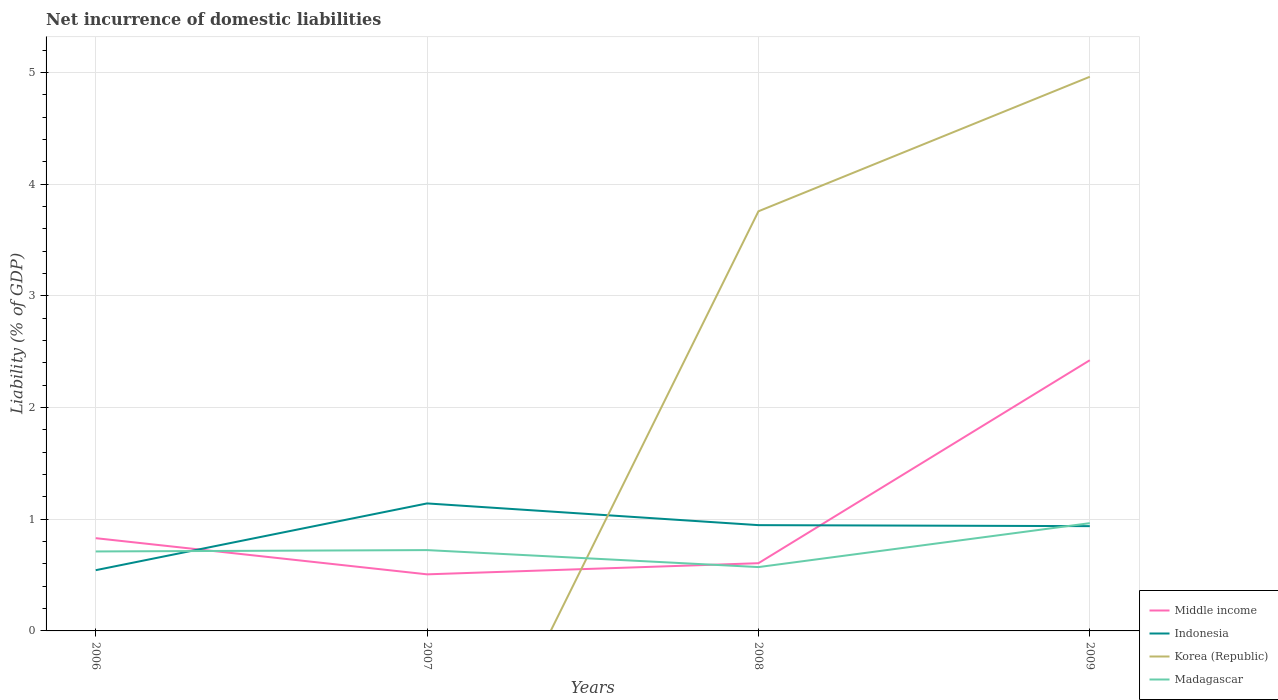How many different coloured lines are there?
Ensure brevity in your answer.  4. Is the number of lines equal to the number of legend labels?
Your answer should be very brief. No. Across all years, what is the maximum net incurrence of domestic liabilities in Madagascar?
Offer a very short reply. 0.57. What is the total net incurrence of domestic liabilities in Madagascar in the graph?
Provide a succinct answer. -0.25. What is the difference between the highest and the second highest net incurrence of domestic liabilities in Madagascar?
Make the answer very short. 0.39. Is the net incurrence of domestic liabilities in Korea (Republic) strictly greater than the net incurrence of domestic liabilities in Indonesia over the years?
Make the answer very short. No. How many years are there in the graph?
Your answer should be very brief. 4. Does the graph contain any zero values?
Provide a short and direct response. Yes. Does the graph contain grids?
Keep it short and to the point. Yes. Where does the legend appear in the graph?
Your response must be concise. Bottom right. How are the legend labels stacked?
Provide a succinct answer. Vertical. What is the title of the graph?
Keep it short and to the point. Net incurrence of domestic liabilities. What is the label or title of the X-axis?
Make the answer very short. Years. What is the label or title of the Y-axis?
Offer a terse response. Liability (% of GDP). What is the Liability (% of GDP) in Middle income in 2006?
Give a very brief answer. 0.83. What is the Liability (% of GDP) of Indonesia in 2006?
Your answer should be compact. 0.54. What is the Liability (% of GDP) of Korea (Republic) in 2006?
Provide a succinct answer. 0. What is the Liability (% of GDP) of Madagascar in 2006?
Provide a succinct answer. 0.71. What is the Liability (% of GDP) in Middle income in 2007?
Offer a very short reply. 0.51. What is the Liability (% of GDP) in Indonesia in 2007?
Offer a terse response. 1.14. What is the Liability (% of GDP) of Madagascar in 2007?
Offer a very short reply. 0.72. What is the Liability (% of GDP) of Middle income in 2008?
Provide a succinct answer. 0.61. What is the Liability (% of GDP) in Indonesia in 2008?
Make the answer very short. 0.95. What is the Liability (% of GDP) of Korea (Republic) in 2008?
Give a very brief answer. 3.76. What is the Liability (% of GDP) of Madagascar in 2008?
Provide a short and direct response. 0.57. What is the Liability (% of GDP) in Middle income in 2009?
Offer a very short reply. 2.42. What is the Liability (% of GDP) of Indonesia in 2009?
Keep it short and to the point. 0.94. What is the Liability (% of GDP) in Korea (Republic) in 2009?
Offer a terse response. 4.96. What is the Liability (% of GDP) of Madagascar in 2009?
Your answer should be compact. 0.97. Across all years, what is the maximum Liability (% of GDP) of Middle income?
Ensure brevity in your answer.  2.42. Across all years, what is the maximum Liability (% of GDP) of Indonesia?
Offer a terse response. 1.14. Across all years, what is the maximum Liability (% of GDP) in Korea (Republic)?
Your answer should be very brief. 4.96. Across all years, what is the maximum Liability (% of GDP) of Madagascar?
Your response must be concise. 0.97. Across all years, what is the minimum Liability (% of GDP) in Middle income?
Make the answer very short. 0.51. Across all years, what is the minimum Liability (% of GDP) in Indonesia?
Make the answer very short. 0.54. Across all years, what is the minimum Liability (% of GDP) in Madagascar?
Provide a short and direct response. 0.57. What is the total Liability (% of GDP) of Middle income in the graph?
Your answer should be compact. 4.37. What is the total Liability (% of GDP) of Indonesia in the graph?
Ensure brevity in your answer.  3.57. What is the total Liability (% of GDP) in Korea (Republic) in the graph?
Provide a short and direct response. 8.72. What is the total Liability (% of GDP) of Madagascar in the graph?
Your answer should be compact. 2.97. What is the difference between the Liability (% of GDP) in Middle income in 2006 and that in 2007?
Provide a short and direct response. 0.32. What is the difference between the Liability (% of GDP) in Indonesia in 2006 and that in 2007?
Ensure brevity in your answer.  -0.6. What is the difference between the Liability (% of GDP) in Madagascar in 2006 and that in 2007?
Offer a terse response. -0.01. What is the difference between the Liability (% of GDP) in Middle income in 2006 and that in 2008?
Provide a short and direct response. 0.22. What is the difference between the Liability (% of GDP) in Indonesia in 2006 and that in 2008?
Make the answer very short. -0.4. What is the difference between the Liability (% of GDP) of Madagascar in 2006 and that in 2008?
Ensure brevity in your answer.  0.14. What is the difference between the Liability (% of GDP) of Middle income in 2006 and that in 2009?
Provide a succinct answer. -1.59. What is the difference between the Liability (% of GDP) in Indonesia in 2006 and that in 2009?
Provide a short and direct response. -0.39. What is the difference between the Liability (% of GDP) of Madagascar in 2006 and that in 2009?
Give a very brief answer. -0.25. What is the difference between the Liability (% of GDP) in Middle income in 2007 and that in 2008?
Provide a short and direct response. -0.1. What is the difference between the Liability (% of GDP) of Indonesia in 2007 and that in 2008?
Your response must be concise. 0.19. What is the difference between the Liability (% of GDP) of Madagascar in 2007 and that in 2008?
Offer a terse response. 0.15. What is the difference between the Liability (% of GDP) of Middle income in 2007 and that in 2009?
Provide a short and direct response. -1.92. What is the difference between the Liability (% of GDP) in Indonesia in 2007 and that in 2009?
Provide a succinct answer. 0.2. What is the difference between the Liability (% of GDP) of Madagascar in 2007 and that in 2009?
Offer a very short reply. -0.24. What is the difference between the Liability (% of GDP) of Middle income in 2008 and that in 2009?
Provide a short and direct response. -1.82. What is the difference between the Liability (% of GDP) in Indonesia in 2008 and that in 2009?
Your answer should be compact. 0.01. What is the difference between the Liability (% of GDP) of Korea (Republic) in 2008 and that in 2009?
Keep it short and to the point. -1.2. What is the difference between the Liability (% of GDP) of Madagascar in 2008 and that in 2009?
Provide a short and direct response. -0.39. What is the difference between the Liability (% of GDP) of Middle income in 2006 and the Liability (% of GDP) of Indonesia in 2007?
Keep it short and to the point. -0.31. What is the difference between the Liability (% of GDP) in Middle income in 2006 and the Liability (% of GDP) in Madagascar in 2007?
Your answer should be very brief. 0.11. What is the difference between the Liability (% of GDP) in Indonesia in 2006 and the Liability (% of GDP) in Madagascar in 2007?
Ensure brevity in your answer.  -0.18. What is the difference between the Liability (% of GDP) in Middle income in 2006 and the Liability (% of GDP) in Indonesia in 2008?
Provide a short and direct response. -0.12. What is the difference between the Liability (% of GDP) in Middle income in 2006 and the Liability (% of GDP) in Korea (Republic) in 2008?
Your answer should be compact. -2.93. What is the difference between the Liability (% of GDP) of Middle income in 2006 and the Liability (% of GDP) of Madagascar in 2008?
Offer a terse response. 0.26. What is the difference between the Liability (% of GDP) in Indonesia in 2006 and the Liability (% of GDP) in Korea (Republic) in 2008?
Make the answer very short. -3.21. What is the difference between the Liability (% of GDP) of Indonesia in 2006 and the Liability (% of GDP) of Madagascar in 2008?
Keep it short and to the point. -0.03. What is the difference between the Liability (% of GDP) in Middle income in 2006 and the Liability (% of GDP) in Indonesia in 2009?
Make the answer very short. -0.11. What is the difference between the Liability (% of GDP) of Middle income in 2006 and the Liability (% of GDP) of Korea (Republic) in 2009?
Offer a terse response. -4.13. What is the difference between the Liability (% of GDP) in Middle income in 2006 and the Liability (% of GDP) in Madagascar in 2009?
Offer a terse response. -0.13. What is the difference between the Liability (% of GDP) in Indonesia in 2006 and the Liability (% of GDP) in Korea (Republic) in 2009?
Offer a very short reply. -4.42. What is the difference between the Liability (% of GDP) of Indonesia in 2006 and the Liability (% of GDP) of Madagascar in 2009?
Give a very brief answer. -0.42. What is the difference between the Liability (% of GDP) of Middle income in 2007 and the Liability (% of GDP) of Indonesia in 2008?
Give a very brief answer. -0.44. What is the difference between the Liability (% of GDP) in Middle income in 2007 and the Liability (% of GDP) in Korea (Republic) in 2008?
Offer a terse response. -3.25. What is the difference between the Liability (% of GDP) in Middle income in 2007 and the Liability (% of GDP) in Madagascar in 2008?
Ensure brevity in your answer.  -0.07. What is the difference between the Liability (% of GDP) of Indonesia in 2007 and the Liability (% of GDP) of Korea (Republic) in 2008?
Provide a short and direct response. -2.62. What is the difference between the Liability (% of GDP) of Indonesia in 2007 and the Liability (% of GDP) of Madagascar in 2008?
Ensure brevity in your answer.  0.57. What is the difference between the Liability (% of GDP) in Middle income in 2007 and the Liability (% of GDP) in Indonesia in 2009?
Give a very brief answer. -0.43. What is the difference between the Liability (% of GDP) in Middle income in 2007 and the Liability (% of GDP) in Korea (Republic) in 2009?
Ensure brevity in your answer.  -4.46. What is the difference between the Liability (% of GDP) of Middle income in 2007 and the Liability (% of GDP) of Madagascar in 2009?
Make the answer very short. -0.46. What is the difference between the Liability (% of GDP) in Indonesia in 2007 and the Liability (% of GDP) in Korea (Republic) in 2009?
Make the answer very short. -3.82. What is the difference between the Liability (% of GDP) of Indonesia in 2007 and the Liability (% of GDP) of Madagascar in 2009?
Give a very brief answer. 0.18. What is the difference between the Liability (% of GDP) in Middle income in 2008 and the Liability (% of GDP) in Indonesia in 2009?
Your answer should be very brief. -0.33. What is the difference between the Liability (% of GDP) in Middle income in 2008 and the Liability (% of GDP) in Korea (Republic) in 2009?
Offer a terse response. -4.36. What is the difference between the Liability (% of GDP) of Middle income in 2008 and the Liability (% of GDP) of Madagascar in 2009?
Ensure brevity in your answer.  -0.36. What is the difference between the Liability (% of GDP) of Indonesia in 2008 and the Liability (% of GDP) of Korea (Republic) in 2009?
Ensure brevity in your answer.  -4.02. What is the difference between the Liability (% of GDP) of Indonesia in 2008 and the Liability (% of GDP) of Madagascar in 2009?
Offer a terse response. -0.02. What is the difference between the Liability (% of GDP) of Korea (Republic) in 2008 and the Liability (% of GDP) of Madagascar in 2009?
Give a very brief answer. 2.79. What is the average Liability (% of GDP) of Middle income per year?
Your response must be concise. 1.09. What is the average Liability (% of GDP) of Indonesia per year?
Provide a succinct answer. 0.89. What is the average Liability (% of GDP) of Korea (Republic) per year?
Your response must be concise. 2.18. What is the average Liability (% of GDP) of Madagascar per year?
Offer a terse response. 0.74. In the year 2006, what is the difference between the Liability (% of GDP) in Middle income and Liability (% of GDP) in Indonesia?
Provide a short and direct response. 0.29. In the year 2006, what is the difference between the Liability (% of GDP) in Middle income and Liability (% of GDP) in Madagascar?
Make the answer very short. 0.12. In the year 2006, what is the difference between the Liability (% of GDP) in Indonesia and Liability (% of GDP) in Madagascar?
Your response must be concise. -0.17. In the year 2007, what is the difference between the Liability (% of GDP) in Middle income and Liability (% of GDP) in Indonesia?
Offer a very short reply. -0.64. In the year 2007, what is the difference between the Liability (% of GDP) in Middle income and Liability (% of GDP) in Madagascar?
Your answer should be compact. -0.22. In the year 2007, what is the difference between the Liability (% of GDP) of Indonesia and Liability (% of GDP) of Madagascar?
Provide a short and direct response. 0.42. In the year 2008, what is the difference between the Liability (% of GDP) in Middle income and Liability (% of GDP) in Indonesia?
Ensure brevity in your answer.  -0.34. In the year 2008, what is the difference between the Liability (% of GDP) in Middle income and Liability (% of GDP) in Korea (Republic)?
Give a very brief answer. -3.15. In the year 2008, what is the difference between the Liability (% of GDP) of Middle income and Liability (% of GDP) of Madagascar?
Give a very brief answer. 0.03. In the year 2008, what is the difference between the Liability (% of GDP) of Indonesia and Liability (% of GDP) of Korea (Republic)?
Ensure brevity in your answer.  -2.81. In the year 2008, what is the difference between the Liability (% of GDP) in Indonesia and Liability (% of GDP) in Madagascar?
Give a very brief answer. 0.38. In the year 2008, what is the difference between the Liability (% of GDP) in Korea (Republic) and Liability (% of GDP) in Madagascar?
Keep it short and to the point. 3.19. In the year 2009, what is the difference between the Liability (% of GDP) of Middle income and Liability (% of GDP) of Indonesia?
Your response must be concise. 1.49. In the year 2009, what is the difference between the Liability (% of GDP) in Middle income and Liability (% of GDP) in Korea (Republic)?
Make the answer very short. -2.54. In the year 2009, what is the difference between the Liability (% of GDP) of Middle income and Liability (% of GDP) of Madagascar?
Provide a short and direct response. 1.46. In the year 2009, what is the difference between the Liability (% of GDP) of Indonesia and Liability (% of GDP) of Korea (Republic)?
Offer a terse response. -4.02. In the year 2009, what is the difference between the Liability (% of GDP) of Indonesia and Liability (% of GDP) of Madagascar?
Offer a very short reply. -0.03. In the year 2009, what is the difference between the Liability (% of GDP) in Korea (Republic) and Liability (% of GDP) in Madagascar?
Provide a succinct answer. 4. What is the ratio of the Liability (% of GDP) of Middle income in 2006 to that in 2007?
Your answer should be very brief. 1.64. What is the ratio of the Liability (% of GDP) in Indonesia in 2006 to that in 2007?
Offer a terse response. 0.48. What is the ratio of the Liability (% of GDP) in Madagascar in 2006 to that in 2007?
Your answer should be compact. 0.98. What is the ratio of the Liability (% of GDP) in Middle income in 2006 to that in 2008?
Your answer should be compact. 1.37. What is the ratio of the Liability (% of GDP) of Indonesia in 2006 to that in 2008?
Provide a short and direct response. 0.57. What is the ratio of the Liability (% of GDP) in Madagascar in 2006 to that in 2008?
Keep it short and to the point. 1.24. What is the ratio of the Liability (% of GDP) of Middle income in 2006 to that in 2009?
Keep it short and to the point. 0.34. What is the ratio of the Liability (% of GDP) in Indonesia in 2006 to that in 2009?
Your answer should be compact. 0.58. What is the ratio of the Liability (% of GDP) in Madagascar in 2006 to that in 2009?
Give a very brief answer. 0.74. What is the ratio of the Liability (% of GDP) in Middle income in 2007 to that in 2008?
Make the answer very short. 0.84. What is the ratio of the Liability (% of GDP) in Indonesia in 2007 to that in 2008?
Offer a terse response. 1.21. What is the ratio of the Liability (% of GDP) in Madagascar in 2007 to that in 2008?
Ensure brevity in your answer.  1.27. What is the ratio of the Liability (% of GDP) of Middle income in 2007 to that in 2009?
Your answer should be very brief. 0.21. What is the ratio of the Liability (% of GDP) in Indonesia in 2007 to that in 2009?
Give a very brief answer. 1.22. What is the ratio of the Liability (% of GDP) of Middle income in 2008 to that in 2009?
Keep it short and to the point. 0.25. What is the ratio of the Liability (% of GDP) of Indonesia in 2008 to that in 2009?
Provide a succinct answer. 1.01. What is the ratio of the Liability (% of GDP) of Korea (Republic) in 2008 to that in 2009?
Your answer should be very brief. 0.76. What is the ratio of the Liability (% of GDP) of Madagascar in 2008 to that in 2009?
Your answer should be very brief. 0.59. What is the difference between the highest and the second highest Liability (% of GDP) of Middle income?
Give a very brief answer. 1.59. What is the difference between the highest and the second highest Liability (% of GDP) in Indonesia?
Your answer should be compact. 0.19. What is the difference between the highest and the second highest Liability (% of GDP) of Madagascar?
Your response must be concise. 0.24. What is the difference between the highest and the lowest Liability (% of GDP) in Middle income?
Provide a short and direct response. 1.92. What is the difference between the highest and the lowest Liability (% of GDP) of Indonesia?
Your answer should be very brief. 0.6. What is the difference between the highest and the lowest Liability (% of GDP) in Korea (Republic)?
Keep it short and to the point. 4.96. What is the difference between the highest and the lowest Liability (% of GDP) of Madagascar?
Provide a short and direct response. 0.39. 